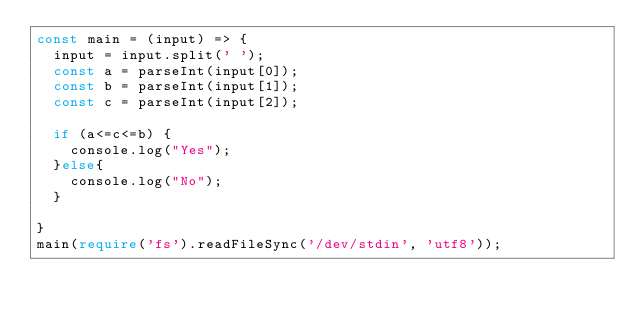Convert code to text. <code><loc_0><loc_0><loc_500><loc_500><_TypeScript_>const main = (input) => {
  input = input.split(' ');
  const a = parseInt(input[0]);
  const b = parseInt(input[1]);
  const c = parseInt(input[2]);
  
  if (a<=c<=b) {
    console.log("Yes");
  }else{
    console.log("No");
  }
  
}
main(require('fs').readFileSync('/dev/stdin', 'utf8'));</code> 